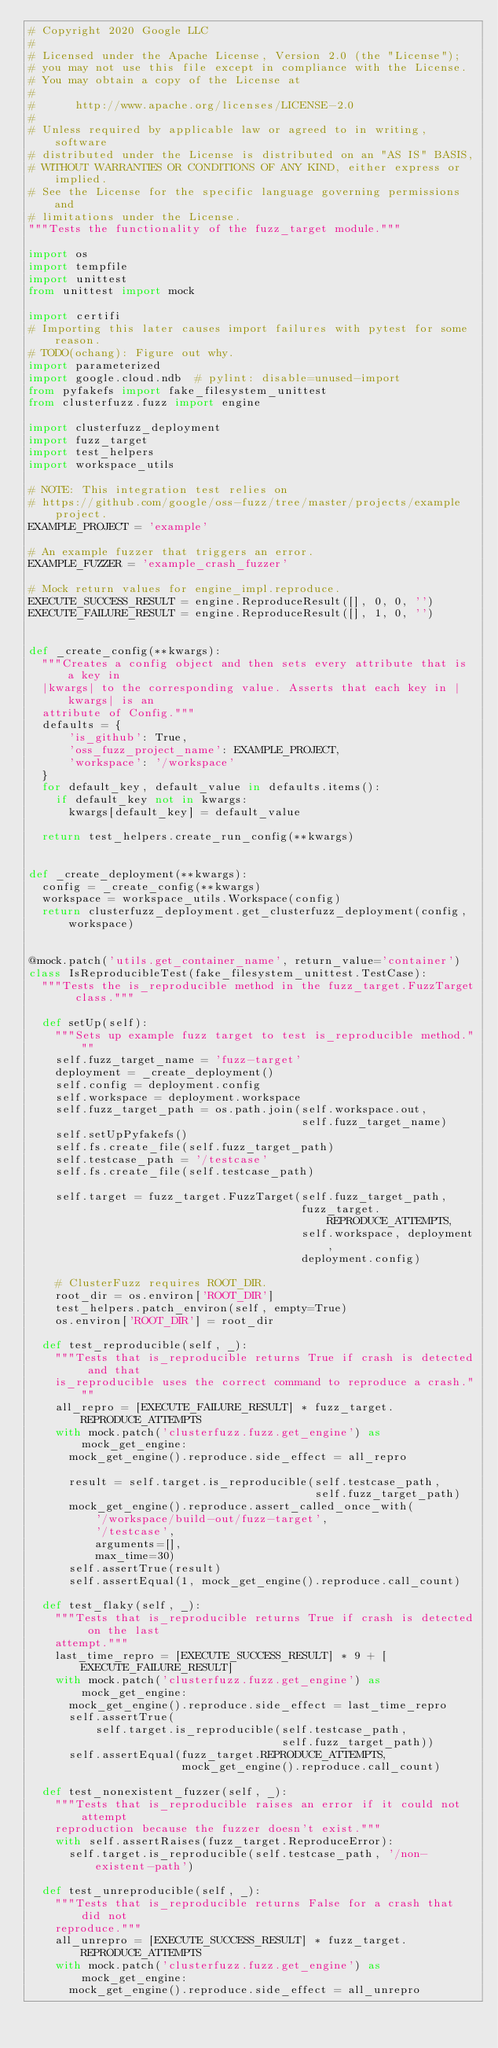Convert code to text. <code><loc_0><loc_0><loc_500><loc_500><_Python_># Copyright 2020 Google LLC
#
# Licensed under the Apache License, Version 2.0 (the "License");
# you may not use this file except in compliance with the License.
# You may obtain a copy of the License at
#
#      http://www.apache.org/licenses/LICENSE-2.0
#
# Unless required by applicable law or agreed to in writing, software
# distributed under the License is distributed on an "AS IS" BASIS,
# WITHOUT WARRANTIES OR CONDITIONS OF ANY KIND, either express or implied.
# See the License for the specific language governing permissions and
# limitations under the License.
"""Tests the functionality of the fuzz_target module."""

import os
import tempfile
import unittest
from unittest import mock

import certifi
# Importing this later causes import failures with pytest for some reason.
# TODO(ochang): Figure out why.
import parameterized
import google.cloud.ndb  # pylint: disable=unused-import
from pyfakefs import fake_filesystem_unittest
from clusterfuzz.fuzz import engine

import clusterfuzz_deployment
import fuzz_target
import test_helpers
import workspace_utils

# NOTE: This integration test relies on
# https://github.com/google/oss-fuzz/tree/master/projects/example project.
EXAMPLE_PROJECT = 'example'

# An example fuzzer that triggers an error.
EXAMPLE_FUZZER = 'example_crash_fuzzer'

# Mock return values for engine_impl.reproduce.
EXECUTE_SUCCESS_RESULT = engine.ReproduceResult([], 0, 0, '')
EXECUTE_FAILURE_RESULT = engine.ReproduceResult([], 1, 0, '')


def _create_config(**kwargs):
  """Creates a config object and then sets every attribute that is a key in
  |kwargs| to the corresponding value. Asserts that each key in |kwargs| is an
  attribute of Config."""
  defaults = {
      'is_github': True,
      'oss_fuzz_project_name': EXAMPLE_PROJECT,
      'workspace': '/workspace'
  }
  for default_key, default_value in defaults.items():
    if default_key not in kwargs:
      kwargs[default_key] = default_value

  return test_helpers.create_run_config(**kwargs)


def _create_deployment(**kwargs):
  config = _create_config(**kwargs)
  workspace = workspace_utils.Workspace(config)
  return clusterfuzz_deployment.get_clusterfuzz_deployment(config, workspace)


@mock.patch('utils.get_container_name', return_value='container')
class IsReproducibleTest(fake_filesystem_unittest.TestCase):
  """Tests the is_reproducible method in the fuzz_target.FuzzTarget class."""

  def setUp(self):
    """Sets up example fuzz target to test is_reproducible method."""
    self.fuzz_target_name = 'fuzz-target'
    deployment = _create_deployment()
    self.config = deployment.config
    self.workspace = deployment.workspace
    self.fuzz_target_path = os.path.join(self.workspace.out,
                                         self.fuzz_target_name)
    self.setUpPyfakefs()
    self.fs.create_file(self.fuzz_target_path)
    self.testcase_path = '/testcase'
    self.fs.create_file(self.testcase_path)

    self.target = fuzz_target.FuzzTarget(self.fuzz_target_path,
                                         fuzz_target.REPRODUCE_ATTEMPTS,
                                         self.workspace, deployment,
                                         deployment.config)

    # ClusterFuzz requires ROOT_DIR.
    root_dir = os.environ['ROOT_DIR']
    test_helpers.patch_environ(self, empty=True)
    os.environ['ROOT_DIR'] = root_dir

  def test_reproducible(self, _):
    """Tests that is_reproducible returns True if crash is detected and that
    is_reproducible uses the correct command to reproduce a crash."""
    all_repro = [EXECUTE_FAILURE_RESULT] * fuzz_target.REPRODUCE_ATTEMPTS
    with mock.patch('clusterfuzz.fuzz.get_engine') as mock_get_engine:
      mock_get_engine().reproduce.side_effect = all_repro

      result = self.target.is_reproducible(self.testcase_path,
                                           self.fuzz_target_path)
      mock_get_engine().reproduce.assert_called_once_with(
          '/workspace/build-out/fuzz-target',
          '/testcase',
          arguments=[],
          max_time=30)
      self.assertTrue(result)
      self.assertEqual(1, mock_get_engine().reproduce.call_count)

  def test_flaky(self, _):
    """Tests that is_reproducible returns True if crash is detected on the last
    attempt."""
    last_time_repro = [EXECUTE_SUCCESS_RESULT] * 9 + [EXECUTE_FAILURE_RESULT]
    with mock.patch('clusterfuzz.fuzz.get_engine') as mock_get_engine:
      mock_get_engine().reproduce.side_effect = last_time_repro
      self.assertTrue(
          self.target.is_reproducible(self.testcase_path,
                                      self.fuzz_target_path))
      self.assertEqual(fuzz_target.REPRODUCE_ATTEMPTS,
                       mock_get_engine().reproduce.call_count)

  def test_nonexistent_fuzzer(self, _):
    """Tests that is_reproducible raises an error if it could not attempt
    reproduction because the fuzzer doesn't exist."""
    with self.assertRaises(fuzz_target.ReproduceError):
      self.target.is_reproducible(self.testcase_path, '/non-existent-path')

  def test_unreproducible(self, _):
    """Tests that is_reproducible returns False for a crash that did not
    reproduce."""
    all_unrepro = [EXECUTE_SUCCESS_RESULT] * fuzz_target.REPRODUCE_ATTEMPTS
    with mock.patch('clusterfuzz.fuzz.get_engine') as mock_get_engine:
      mock_get_engine().reproduce.side_effect = all_unrepro</code> 